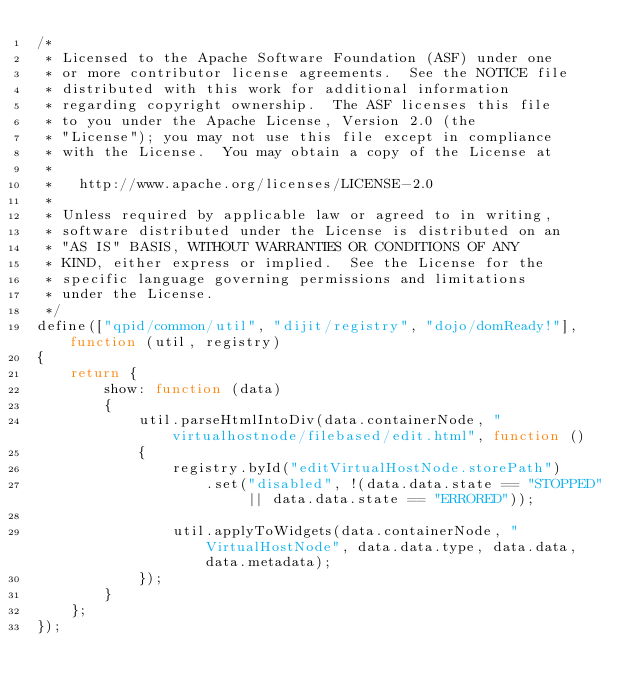Convert code to text. <code><loc_0><loc_0><loc_500><loc_500><_JavaScript_>/*
 * Licensed to the Apache Software Foundation (ASF) under one
 * or more contributor license agreements.  See the NOTICE file
 * distributed with this work for additional information
 * regarding copyright ownership.  The ASF licenses this file
 * to you under the Apache License, Version 2.0 (the
 * "License"); you may not use this file except in compliance
 * with the License.  You may obtain a copy of the License at
 *
 *   http://www.apache.org/licenses/LICENSE-2.0
 *
 * Unless required by applicable law or agreed to in writing,
 * software distributed under the License is distributed on an
 * "AS IS" BASIS, WITHOUT WARRANTIES OR CONDITIONS OF ANY
 * KIND, either express or implied.  See the License for the
 * specific language governing permissions and limitations
 * under the License.
 */
define(["qpid/common/util", "dijit/registry", "dojo/domReady!"], function (util, registry)
{
    return {
        show: function (data)
        {
            util.parseHtmlIntoDiv(data.containerNode, "virtualhostnode/filebased/edit.html", function ()
            {
                registry.byId("editVirtualHostNode.storePath")
                    .set("disabled", !(data.data.state == "STOPPED" || data.data.state == "ERRORED"));

                util.applyToWidgets(data.containerNode, "VirtualHostNode", data.data.type, data.data, data.metadata);
            });
        }
    };
});
</code> 